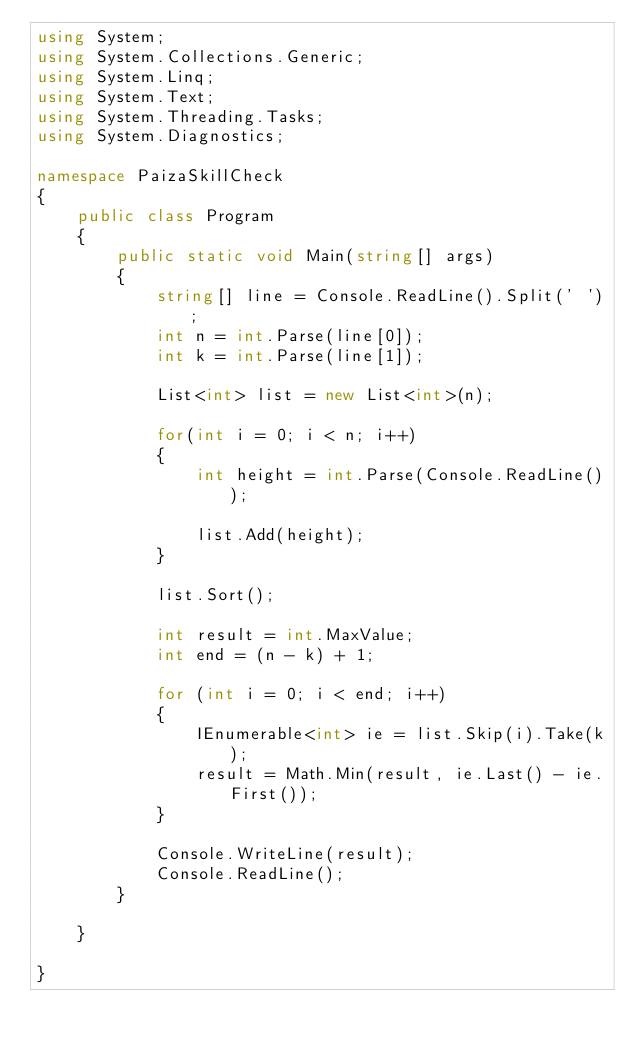<code> <loc_0><loc_0><loc_500><loc_500><_C#_>using System;
using System.Collections.Generic;
using System.Linq;
using System.Text;
using System.Threading.Tasks;
using System.Diagnostics;

namespace PaizaSkillCheck
{
    public class Program
    {
        public static void Main(string[] args)
        {
            string[] line = Console.ReadLine().Split(' ');
            int n = int.Parse(line[0]);
            int k = int.Parse(line[1]);

            List<int> list = new List<int>(n);

            for(int i = 0; i < n; i++)
            {
                int height = int.Parse(Console.ReadLine());

                list.Add(height);
            }

            list.Sort();

            int result = int.MaxValue;
            int end = (n - k) + 1;

            for (int i = 0; i < end; i++)
            {
                IEnumerable<int> ie = list.Skip(i).Take(k);
                result = Math.Min(result, ie.Last() - ie.First());
            }

            Console.WriteLine(result);
            Console.ReadLine();
        }

    }

}
</code> 